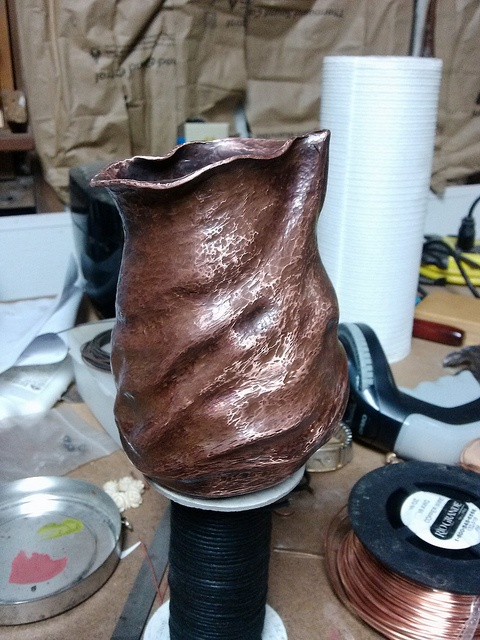Describe the objects in this image and their specific colors. I can see a vase in gray, maroon, brown, and black tones in this image. 